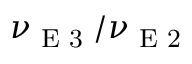Convert formula to latex. <formula><loc_0><loc_0><loc_500><loc_500>\nu _ { E 3 } / \nu _ { E 2 }</formula> 